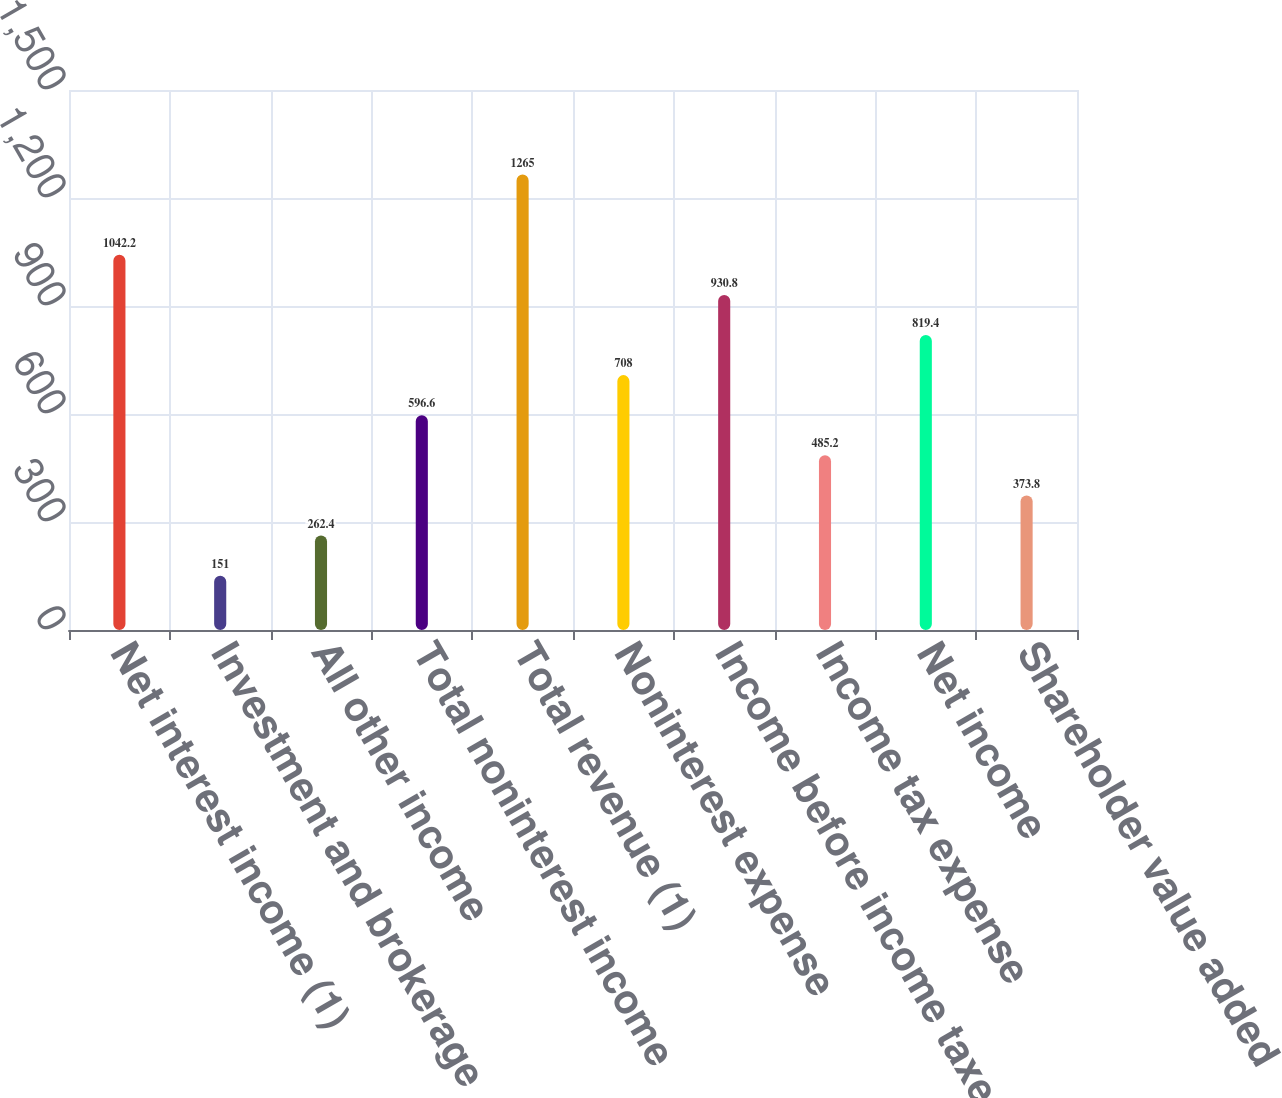<chart> <loc_0><loc_0><loc_500><loc_500><bar_chart><fcel>Net interest income (1)<fcel>Investment and brokerage<fcel>All other income<fcel>Total noninterest income<fcel>Total revenue (1)<fcel>Noninterest expense<fcel>Income before income taxes (1)<fcel>Income tax expense<fcel>Net income<fcel>Shareholder value added<nl><fcel>1042.2<fcel>151<fcel>262.4<fcel>596.6<fcel>1265<fcel>708<fcel>930.8<fcel>485.2<fcel>819.4<fcel>373.8<nl></chart> 